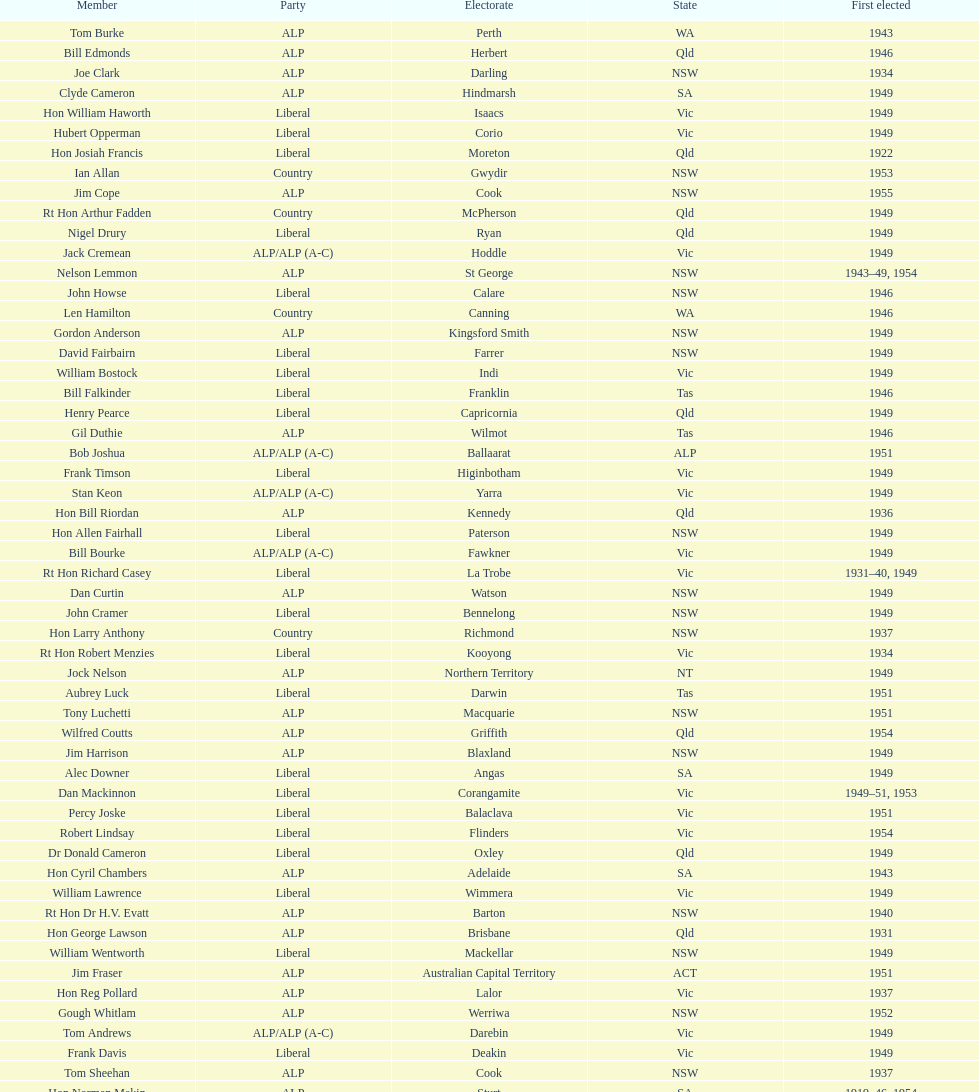Which party was elected the least? Country. Write the full table. {'header': ['Member', 'Party', 'Electorate', 'State', 'First elected'], 'rows': [['Tom Burke', 'ALP', 'Perth', 'WA', '1943'], ['Bill Edmonds', 'ALP', 'Herbert', 'Qld', '1946'], ['Joe Clark', 'ALP', 'Darling', 'NSW', '1934'], ['Clyde Cameron', 'ALP', 'Hindmarsh', 'SA', '1949'], ['Hon William Haworth', 'Liberal', 'Isaacs', 'Vic', '1949'], ['Hubert Opperman', 'Liberal', 'Corio', 'Vic', '1949'], ['Hon Josiah Francis', 'Liberal', 'Moreton', 'Qld', '1922'], ['Ian Allan', 'Country', 'Gwydir', 'NSW', '1953'], ['Jim Cope', 'ALP', 'Cook', 'NSW', '1955'], ['Rt Hon Arthur Fadden', 'Country', 'McPherson', 'Qld', '1949'], ['Nigel Drury', 'Liberal', 'Ryan', 'Qld', '1949'], ['Jack Cremean', 'ALP/ALP (A-C)', 'Hoddle', 'Vic', '1949'], ['Nelson Lemmon', 'ALP', 'St George', 'NSW', '1943–49, 1954'], ['John Howse', 'Liberal', 'Calare', 'NSW', '1946'], ['Len Hamilton', 'Country', 'Canning', 'WA', '1946'], ['Gordon Anderson', 'ALP', 'Kingsford Smith', 'NSW', '1949'], ['David Fairbairn', 'Liberal', 'Farrer', 'NSW', '1949'], ['William Bostock', 'Liberal', 'Indi', 'Vic', '1949'], ['Bill Falkinder', 'Liberal', 'Franklin', 'Tas', '1946'], ['Henry Pearce', 'Liberal', 'Capricornia', 'Qld', '1949'], ['Gil Duthie', 'ALP', 'Wilmot', 'Tas', '1946'], ['Bob Joshua', 'ALP/ALP (A-C)', 'Ballaarat', 'ALP', '1951'], ['Frank Timson', 'Liberal', 'Higinbotham', 'Vic', '1949'], ['Stan Keon', 'ALP/ALP (A-C)', 'Yarra', 'Vic', '1949'], ['Hon Bill Riordan', 'ALP', 'Kennedy', 'Qld', '1936'], ['Hon Allen Fairhall', 'Liberal', 'Paterson', 'NSW', '1949'], ['Bill Bourke', 'ALP/ALP (A-C)', 'Fawkner', 'Vic', '1949'], ['Rt Hon Richard Casey', 'Liberal', 'La Trobe', 'Vic', '1931–40, 1949'], ['Dan Curtin', 'ALP', 'Watson', 'NSW', '1949'], ['John Cramer', 'Liberal', 'Bennelong', 'NSW', '1949'], ['Hon Larry Anthony', 'Country', 'Richmond', 'NSW', '1937'], ['Rt Hon Robert Menzies', 'Liberal', 'Kooyong', 'Vic', '1934'], ['Jock Nelson', 'ALP', 'Northern Territory', 'NT', '1949'], ['Aubrey Luck', 'Liberal', 'Darwin', 'Tas', '1951'], ['Tony Luchetti', 'ALP', 'Macquarie', 'NSW', '1951'], ['Wilfred Coutts', 'ALP', 'Griffith', 'Qld', '1954'], ['Jim Harrison', 'ALP', 'Blaxland', 'NSW', '1949'], ['Alec Downer', 'Liberal', 'Angas', 'SA', '1949'], ['Dan Mackinnon', 'Liberal', 'Corangamite', 'Vic', '1949–51, 1953'], ['Percy Joske', 'Liberal', 'Balaclava', 'Vic', '1951'], ['Robert Lindsay', 'Liberal', 'Flinders', 'Vic', '1954'], ['Dr Donald Cameron', 'Liberal', 'Oxley', 'Qld', '1949'], ['Hon Cyril Chambers', 'ALP', 'Adelaide', 'SA', '1943'], ['William Lawrence', 'Liberal', 'Wimmera', 'Vic', '1949'], ['Rt Hon Dr H.V. Evatt', 'ALP', 'Barton', 'NSW', '1940'], ['Hon George Lawson', 'ALP', 'Brisbane', 'Qld', '1931'], ['William Wentworth', 'Liberal', 'Mackellar', 'NSW', '1949'], ['Jim Fraser', 'ALP', 'Australian Capital Territory', 'ACT', '1951'], ['Hon Reg Pollard', 'ALP', 'Lalor', 'Vic', '1937'], ['Gough Whitlam', 'ALP', 'Werriwa', 'NSW', '1952'], ['Tom Andrews', 'ALP/ALP (A-C)', 'Darebin', 'Vic', '1949'], ['Frank Davis', 'Liberal', 'Deakin', 'Vic', '1949'], ['Tom Sheehan', 'ALP', 'Cook', 'NSW', '1937'], ['Hon Norman Makin', 'ALP', 'Sturt', 'SA', '1919–46, 1954'], ['Lance Barnard', 'ALP', 'Bass', 'Tas', '1954'], ['Roger Dean', 'Liberal', 'Robertson', 'NSW', '1949'], ['Hon Paul Hasluck', 'Liberal', 'Curtin', 'WA', '1949'], ['Hon Arthur Drakeford', 'ALP', 'Maribyrnong', 'Vic', '1934'], ['Hon Frederick Osborne', 'Liberal', 'Evans', 'NSW', '1949'], ['Malcolm McColm', 'Liberal', 'Bowman', 'Qld', '1949'], ['Charles Davidson', 'Country', 'Dawson', 'Qld', '1946'], ["William O'Connor", 'ALP', 'Martin', 'NSW', '1946'], ['Joe Fitzgerald', 'ALP', 'Phillip', 'NSW', '1949'], ['Rowley James', 'ALP', 'Hunter', 'NSW', '1928'], ['Rt Hon Harold Holt', 'Liberal', 'Higgins', 'Vic', '1935'], ['Kim Beazley', 'ALP', 'Fremantle', 'WA', '1945'], ['Hon David Drummond', 'Country', 'New England', 'NSW', '1949'], ['Hon Archie Cameron', 'Liberal', 'Barker', 'SA', '1934'], ['Hon Arthur Calwell', 'ALP', 'Melbourne', 'Vic', '1940'], ['Francis Bland', 'Liberal', 'Warringah', 'NSW', '1951'], ['Allan Fraser', 'ALP', 'Eden-Monaro', 'NSW', '1943'], ['Pat Galvin', 'ALP', 'Kingston', 'SA', '1951'], ['Albert Thompson', 'ALP', 'Port Adelaide', 'SA', '1946'], ['Charles Adermann', 'Country', 'Fisher', 'Qld', '1943'], ['Hon Percy Clarey', 'ALP', 'Bendigo', 'Vic', '1949'], ['Wilfred Brimblecombe', 'Country', 'Maranoa', 'Qld', '1951'], ['Edgar Russell', 'ALP', 'Grey', 'SA', '1943'], ['David Oliver Watkins', 'ALP', 'Newcastle', 'NSW', '1935'], ['Charles Morgan', 'ALP', 'Reid', 'NSW', '1940–46, 1949'], ['Ted Peters', 'ALP', 'Burke', 'Vic', '1949'], ['Alan Bird', 'ALP', 'Batman', 'Vic', '1949'], ['Philip Lucock', 'Country', 'Lyne', 'NSW', '1953'], ['Rt Hon Eric Harrison', 'Liberal', 'Wentworth', 'NSW', '1931'], ['John McLeay', 'Liberal', 'Boothby', 'SA', '1949'], ['Bruce Wight', 'Liberal', 'Lilley', 'Qld', '1949'], ['Jo Gullett', 'Liberal', 'Henty', 'Vic', '1946'], ['Don McLeod', 'Liberal', 'Wannon', 'ALP', '1940–49, 1951'], ['Harry Turner', 'Liberal', 'Bradfield', 'NSW', '1952'], ['Reginald Swartz', 'Liberal', 'Darling Downs', 'Qld', '1949'], ['Winton Turnbull', 'Country', 'Mallee', 'Vic', '1946'], ['Hugh Roberton', 'Country', 'Riverina', 'NSW', '1949'], ['Charles Griffiths', 'ALP', 'Shortland', 'NSW', '1949'], ['Arthur Greenup', 'ALP', 'Dalley', 'NSW', '1953'], ['William Brand', 'Country', 'Wide Bay', 'Qld', '1954'], ['Geoffrey Brown', 'Liberal', 'McMillan', 'Vic', '1949'], ['Hon Herbert Johnson', 'ALP', 'Kalgoorlie', 'WA', '1940'], ['Leslie Haylen', 'ALP', 'Parkes', 'NSW', '1943'], ['Billy Davies', 'ALP', 'Cunningham', 'NSW', '1949'], ['Gordon Freeth', 'Liberal', 'Forrest', 'WA', '1949'], ['Dan Minogue', 'ALP', 'West Sydney', 'NSW', '1949'], ['Hon Philip McBride', 'Liberal', 'Wakefield', 'SA', '1931–37, 1937–43 (S), 1946'], ['Rt Hon Sir Earle Page', 'Country', 'Cowper', 'NSW', '1919'], ['Hon Harry Bruce', 'ALP', 'Leichhardt', 'Qld', '1951'], ['Harry Webb', 'ALP', 'Swan', 'WA', '1954'], ['Frank Stewart', 'ALP', 'Lang', 'NSW', '1953'], ['Hon Eddie Ward', 'ALP', 'East Sydney', 'NSW', '1931, 1932'], ['Frank Crean', 'ALP', 'Melbourne Ports', 'Vic', '1951'], ['Jeff Bate', 'Liberal', 'Macarthur', 'NSW', '1949'], ['Roy Wheeler', 'Liberal', 'Mitchell', 'NSW', '1949'], ['Jack Mullens', 'ALP/ALP (A-C)', 'Gellibrand', 'Vic', '1949'], ['George Bowden', 'Country', 'Gippsland', 'Vic', '1943'], ['Dominic Costa', 'ALP', 'Banks', 'NSW', '1949'], ['Hugh Leslie', 'Liberal', 'Moore', 'Country', '1949'], ['Hon William McMahon', 'Liberal', 'Lowe', 'NSW', '1949'], ['Hon Wilfrid Kent Hughes', 'Liberal', 'Chisholm', 'Vic', '1949'], ['Alan Hulme', 'Liberal', 'Petrie', 'Qld', '1949'], ['Hon Howard Beale', 'Liberal', 'Parramatta', 'NSW', '1946'], ['Rt Hon John McEwen', 'Country', 'Murray', 'Vic', '1934'], ['Arthur Fuller', 'Country', 'Hume', 'NSW', '1943–49, 1951'], ['Bill Bryson', 'ALP/ALP (A-C)', 'Wills', 'Vic', '1943–1946, 1949'], ['Laurie Failes', 'Country', 'Lawson', 'NSW', '1949'], ['William Jack', 'Liberal', 'North Sydney', 'NSW', '1949'], ['Fred Daly', 'ALP', 'Grayndler', 'NSW', '1943'], ['Hon Athol Townley', 'Liberal', 'Denison', 'Tas', '1949']]} 